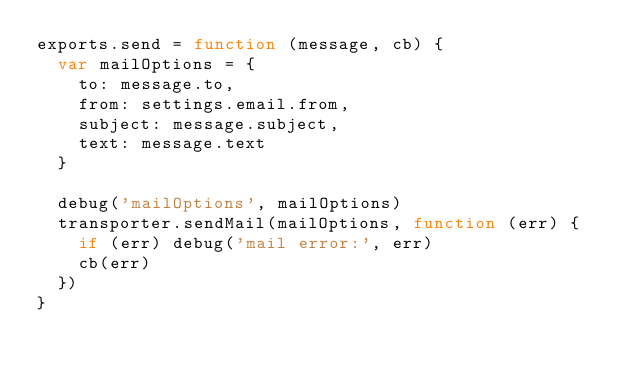<code> <loc_0><loc_0><loc_500><loc_500><_JavaScript_>exports.send = function (message, cb) {
  var mailOptions = {
    to: message.to,
    from: settings.email.from,
    subject: message.subject,
    text: message.text
  }

  debug('mailOptions', mailOptions)
  transporter.sendMail(mailOptions, function (err) {
    if (err) debug('mail error:', err)
    cb(err)
  })
}
</code> 